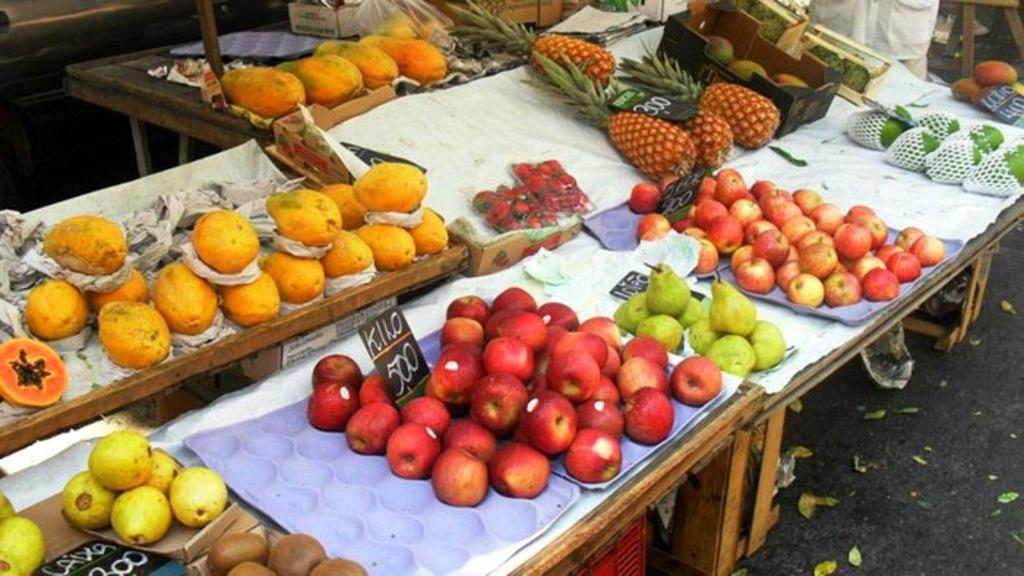What is on the table in the image? There are fruits on a table in the image. Can you describe the background of the image? There is a person and a plastic bag in the background of the image. What type of collar can be seen on the baby in the image? There is no baby present in the image, so there is no collar to be seen. 